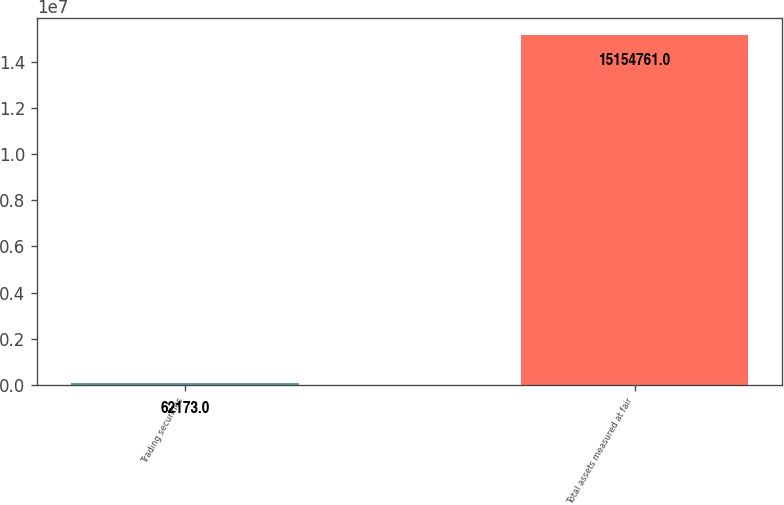<chart> <loc_0><loc_0><loc_500><loc_500><bar_chart><fcel>Trading securities<fcel>Total assets measured at fair<nl><fcel>62173<fcel>1.51548e+07<nl></chart> 